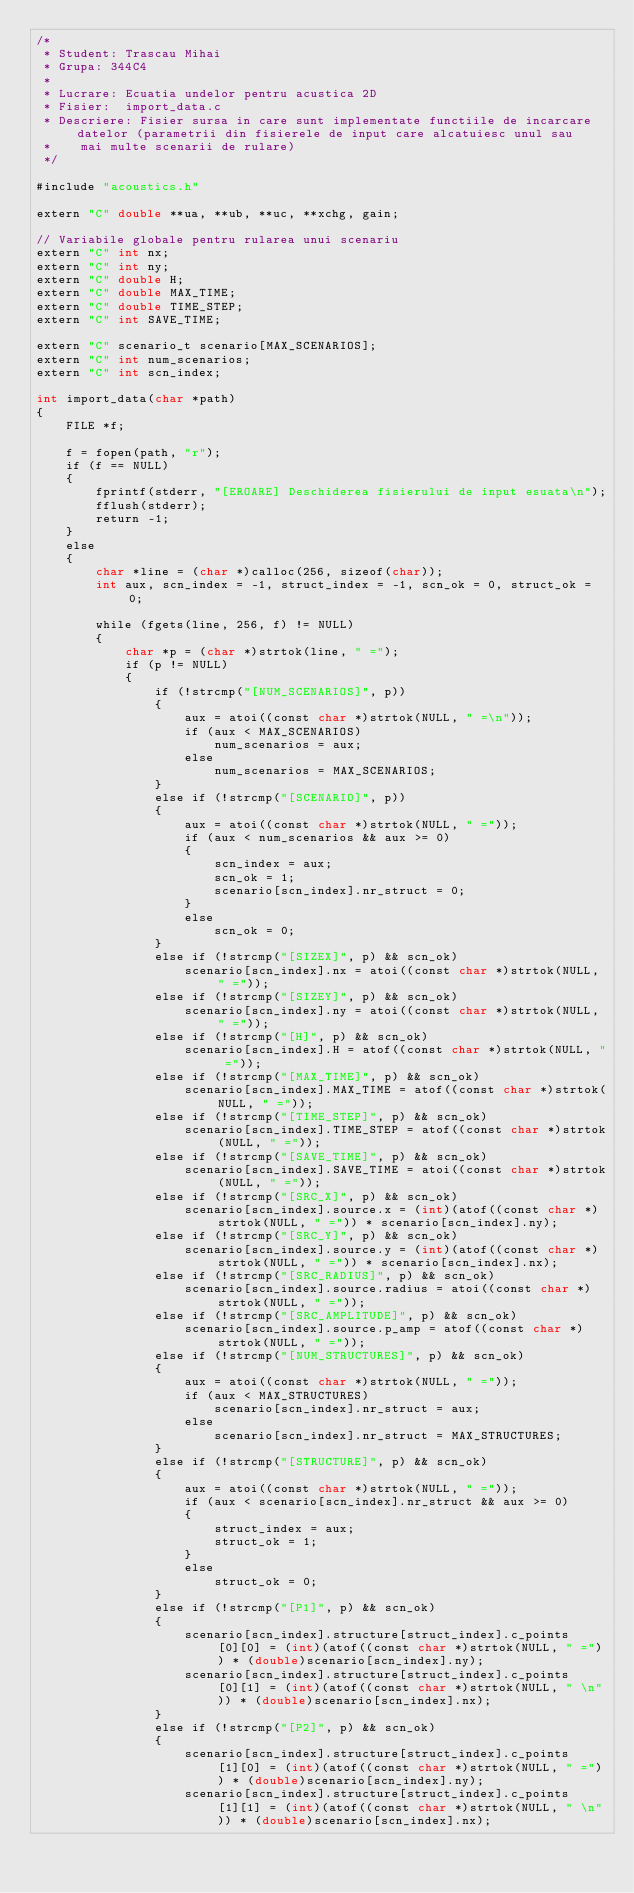Convert code to text. <code><loc_0><loc_0><loc_500><loc_500><_Cuda_>/*
 * Student:	Trascau Mihai
 * Grupa:	344C4
 * 
 * Lucrare:	Ecuatia undelor pentru acustica 2D
 * Fisier:	import_data.c
 * Descriere:	Fisier sursa in care sunt implementate functiile de incarcare datelor (parametrii din fisierele de input care alcatuiesc unul sau
 * 		mai multe scenarii de rulare)
 */

#include "acoustics.h"

extern "C" double **ua, **ub, **uc, **xchg, gain;

// Variabile globale pentru rularea unui scenariu
extern "C" int nx;
extern "C" int ny;
extern "C" double H;
extern "C" double MAX_TIME;
extern "C" double TIME_STEP;
extern "C" int SAVE_TIME;

extern "C" scenario_t scenario[MAX_SCENARIOS];
extern "C" int num_scenarios;
extern "C" int scn_index;

int import_data(char *path)
{
    FILE *f;

    f = fopen(path, "r");
    if (f == NULL)
    {
        fprintf(stderr, "[EROARE] Deschiderea fisierului de input esuata\n");
        fflush(stderr);
        return -1;
    }
    else
    {
        char *line = (char *)calloc(256, sizeof(char));
        int aux, scn_index = -1, struct_index = -1, scn_ok = 0, struct_ok = 0;

        while (fgets(line, 256, f) != NULL)
        {
            char *p = (char *)strtok(line, " =");
            if (p != NULL)
            {
                if (!strcmp("[NUM_SCENARIOS]", p))
                {
                    aux = atoi((const char *)strtok(NULL, " =\n"));
                    if (aux < MAX_SCENARIOS)
                        num_scenarios = aux;
                    else
                        num_scenarios = MAX_SCENARIOS;
                }
                else if (!strcmp("[SCENARIO]", p))
                {
                    aux = atoi((const char *)strtok(NULL, " ="));
                    if (aux < num_scenarios && aux >= 0)
                    {
                        scn_index = aux;
                        scn_ok = 1;
                        scenario[scn_index].nr_struct = 0;
                    }
                    else
                        scn_ok = 0;
                }
                else if (!strcmp("[SIZEX]", p) && scn_ok)
                    scenario[scn_index].nx = atoi((const char *)strtok(NULL, " ="));
                else if (!strcmp("[SIZEY]", p) && scn_ok)
                    scenario[scn_index].ny = atoi((const char *)strtok(NULL, " ="));
                else if (!strcmp("[H]", p) && scn_ok)
                    scenario[scn_index].H = atof((const char *)strtok(NULL, " ="));
                else if (!strcmp("[MAX_TIME]", p) && scn_ok)
                    scenario[scn_index].MAX_TIME = atof((const char *)strtok(NULL, " ="));
                else if (!strcmp("[TIME_STEP]", p) && scn_ok)
                    scenario[scn_index].TIME_STEP = atof((const char *)strtok(NULL, " ="));
                else if (!strcmp("[SAVE_TIME]", p) && scn_ok)
                    scenario[scn_index].SAVE_TIME = atoi((const char *)strtok(NULL, " ="));
                else if (!strcmp("[SRC_X]", p) && scn_ok)
                    scenario[scn_index].source.x = (int)(atof((const char *)strtok(NULL, " =")) * scenario[scn_index].ny);
                else if (!strcmp("[SRC_Y]", p) && scn_ok)
                    scenario[scn_index].source.y = (int)(atof((const char *)strtok(NULL, " =")) * scenario[scn_index].nx);
                else if (!strcmp("[SRC_RADIUS]", p) && scn_ok)
                    scenario[scn_index].source.radius = atoi((const char *)strtok(NULL, " ="));
                else if (!strcmp("[SRC_AMPLITUDE]", p) && scn_ok)
                    scenario[scn_index].source.p_amp = atof((const char *)strtok(NULL, " ="));
                else if (!strcmp("[NUM_STRUCTURES]", p) && scn_ok)
                {
                    aux = atoi((const char *)strtok(NULL, " ="));
                    if (aux < MAX_STRUCTURES)
                        scenario[scn_index].nr_struct = aux;
                    else
                        scenario[scn_index].nr_struct = MAX_STRUCTURES;
                }
                else if (!strcmp("[STRUCTURE]", p) && scn_ok)
                {
                    aux = atoi((const char *)strtok(NULL, " ="));
                    if (aux < scenario[scn_index].nr_struct && aux >= 0)
                    {
                        struct_index = aux;
                        struct_ok = 1;
                    }
                    else
                        struct_ok = 0;
                }
                else if (!strcmp("[P1]", p) && scn_ok)
                {
                    scenario[scn_index].structure[struct_index].c_points[0][0] = (int)(atof((const char *)strtok(NULL, " =")) * (double)scenario[scn_index].ny);
                    scenario[scn_index].structure[struct_index].c_points[0][1] = (int)(atof((const char *)strtok(NULL, " \n")) * (double)scenario[scn_index].nx);
                }
                else if (!strcmp("[P2]", p) && scn_ok)
                {
                    scenario[scn_index].structure[struct_index].c_points[1][0] = (int)(atof((const char *)strtok(NULL, " =")) * (double)scenario[scn_index].ny);
                    scenario[scn_index].structure[struct_index].c_points[1][1] = (int)(atof((const char *)strtok(NULL, " \n")) * (double)scenario[scn_index].nx);</code> 